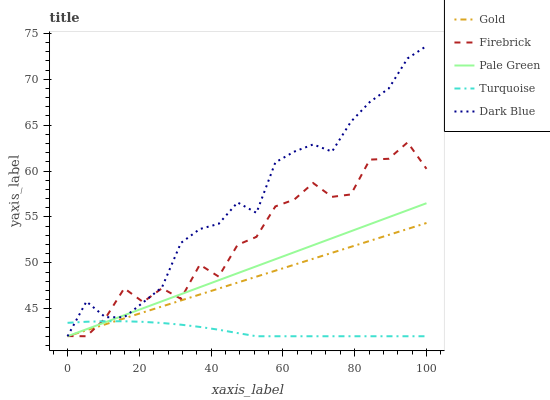Does Turquoise have the minimum area under the curve?
Answer yes or no. Yes. Does Dark Blue have the maximum area under the curve?
Answer yes or no. Yes. Does Firebrick have the minimum area under the curve?
Answer yes or no. No. Does Firebrick have the maximum area under the curve?
Answer yes or no. No. Is Pale Green the smoothest?
Answer yes or no. Yes. Is Firebrick the roughest?
Answer yes or no. Yes. Is Firebrick the smoothest?
Answer yes or no. No. Is Pale Green the roughest?
Answer yes or no. No. Does Dark Blue have the highest value?
Answer yes or no. Yes. Does Firebrick have the highest value?
Answer yes or no. No. Does Turquoise intersect Dark Blue?
Answer yes or no. Yes. Is Turquoise less than Dark Blue?
Answer yes or no. No. Is Turquoise greater than Dark Blue?
Answer yes or no. No. 